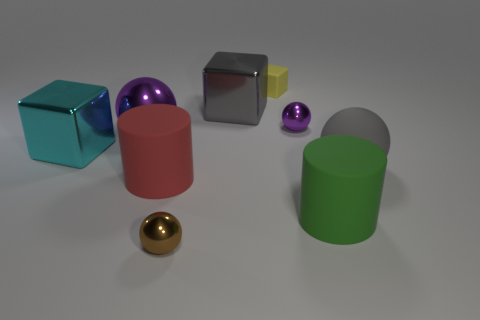Subtract all cyan cylinders. Subtract all gray spheres. How many cylinders are left? 2 Add 1 tiny brown cylinders. How many objects exist? 10 Subtract all cylinders. How many objects are left? 7 Add 5 gray objects. How many gray objects are left? 7 Add 1 blue matte balls. How many blue matte balls exist? 1 Subtract 0 blue cylinders. How many objects are left? 9 Subtract all small yellow things. Subtract all tiny blocks. How many objects are left? 7 